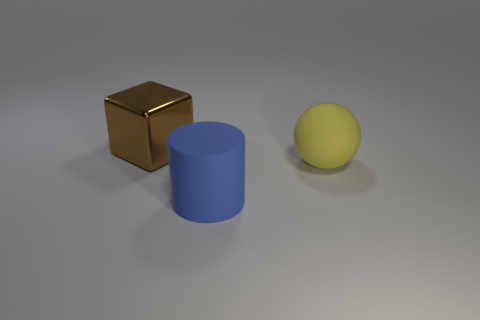Add 3 red shiny balls. How many objects exist? 6 Subtract all blocks. How many objects are left? 2 Subtract all small gray cylinders. Subtract all cubes. How many objects are left? 2 Add 3 yellow objects. How many yellow objects are left? 4 Add 1 big matte objects. How many big matte objects exist? 3 Subtract 0 gray cubes. How many objects are left? 3 